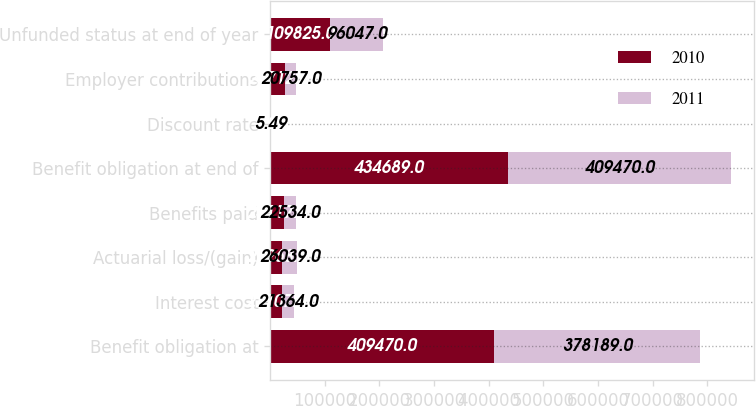<chart> <loc_0><loc_0><loc_500><loc_500><stacked_bar_chart><ecel><fcel>Benefit obligation at<fcel>Interest cost<fcel>Actuarial loss/(gain)<fcel>Benefits paid<fcel>Benefit obligation at end of<fcel>Discount rate<fcel>Employer contributions<fcel>Unfunded status at end of year<nl><fcel>2010<fcel>409470<fcel>21707<fcel>22268<fcel>25117<fcel>434689<fcel>4.98<fcel>26712<fcel>109825<nl><fcel>2011<fcel>378189<fcel>21364<fcel>26039<fcel>22534<fcel>409470<fcel>5.49<fcel>20757<fcel>96047<nl></chart> 